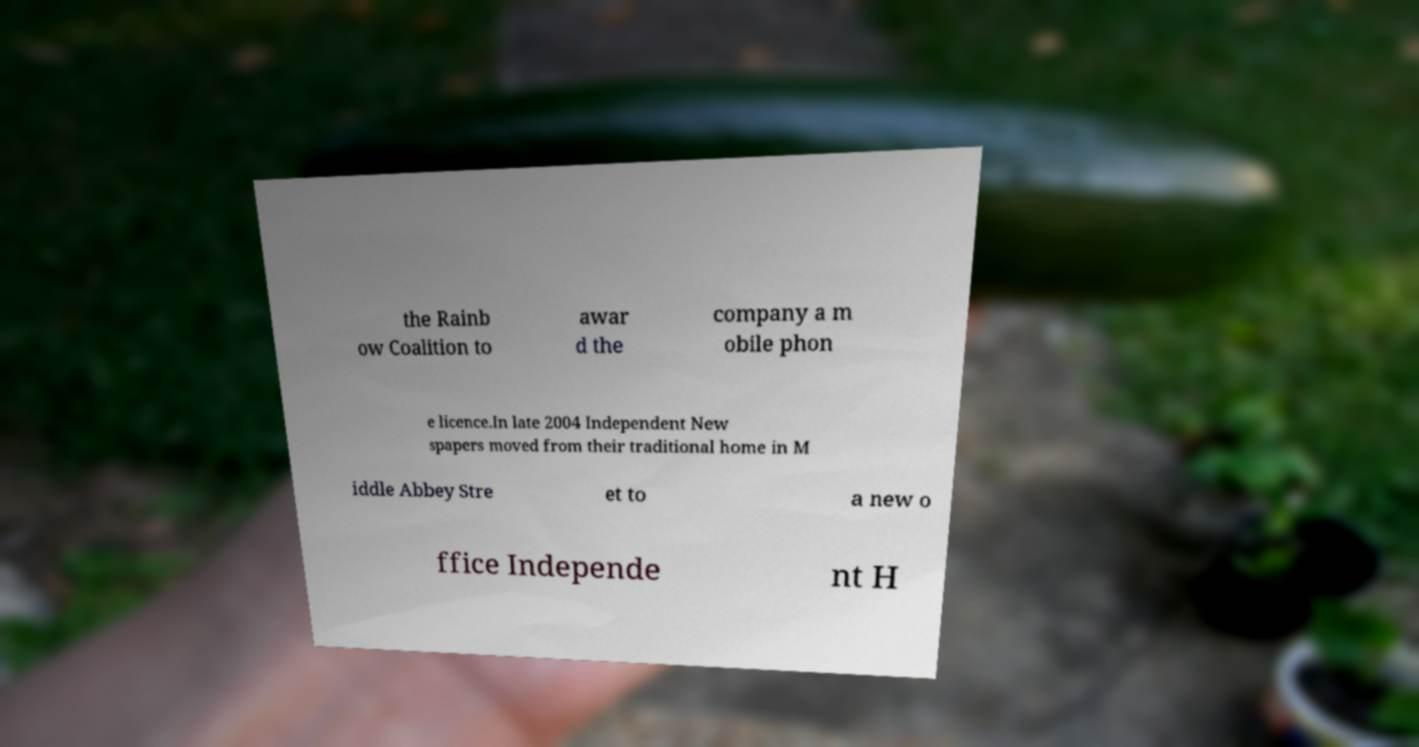Please read and relay the text visible in this image. What does it say? the Rainb ow Coalition to awar d the company a m obile phon e licence.In late 2004 Independent New spapers moved from their traditional home in M iddle Abbey Stre et to a new o ffice Independe nt H 